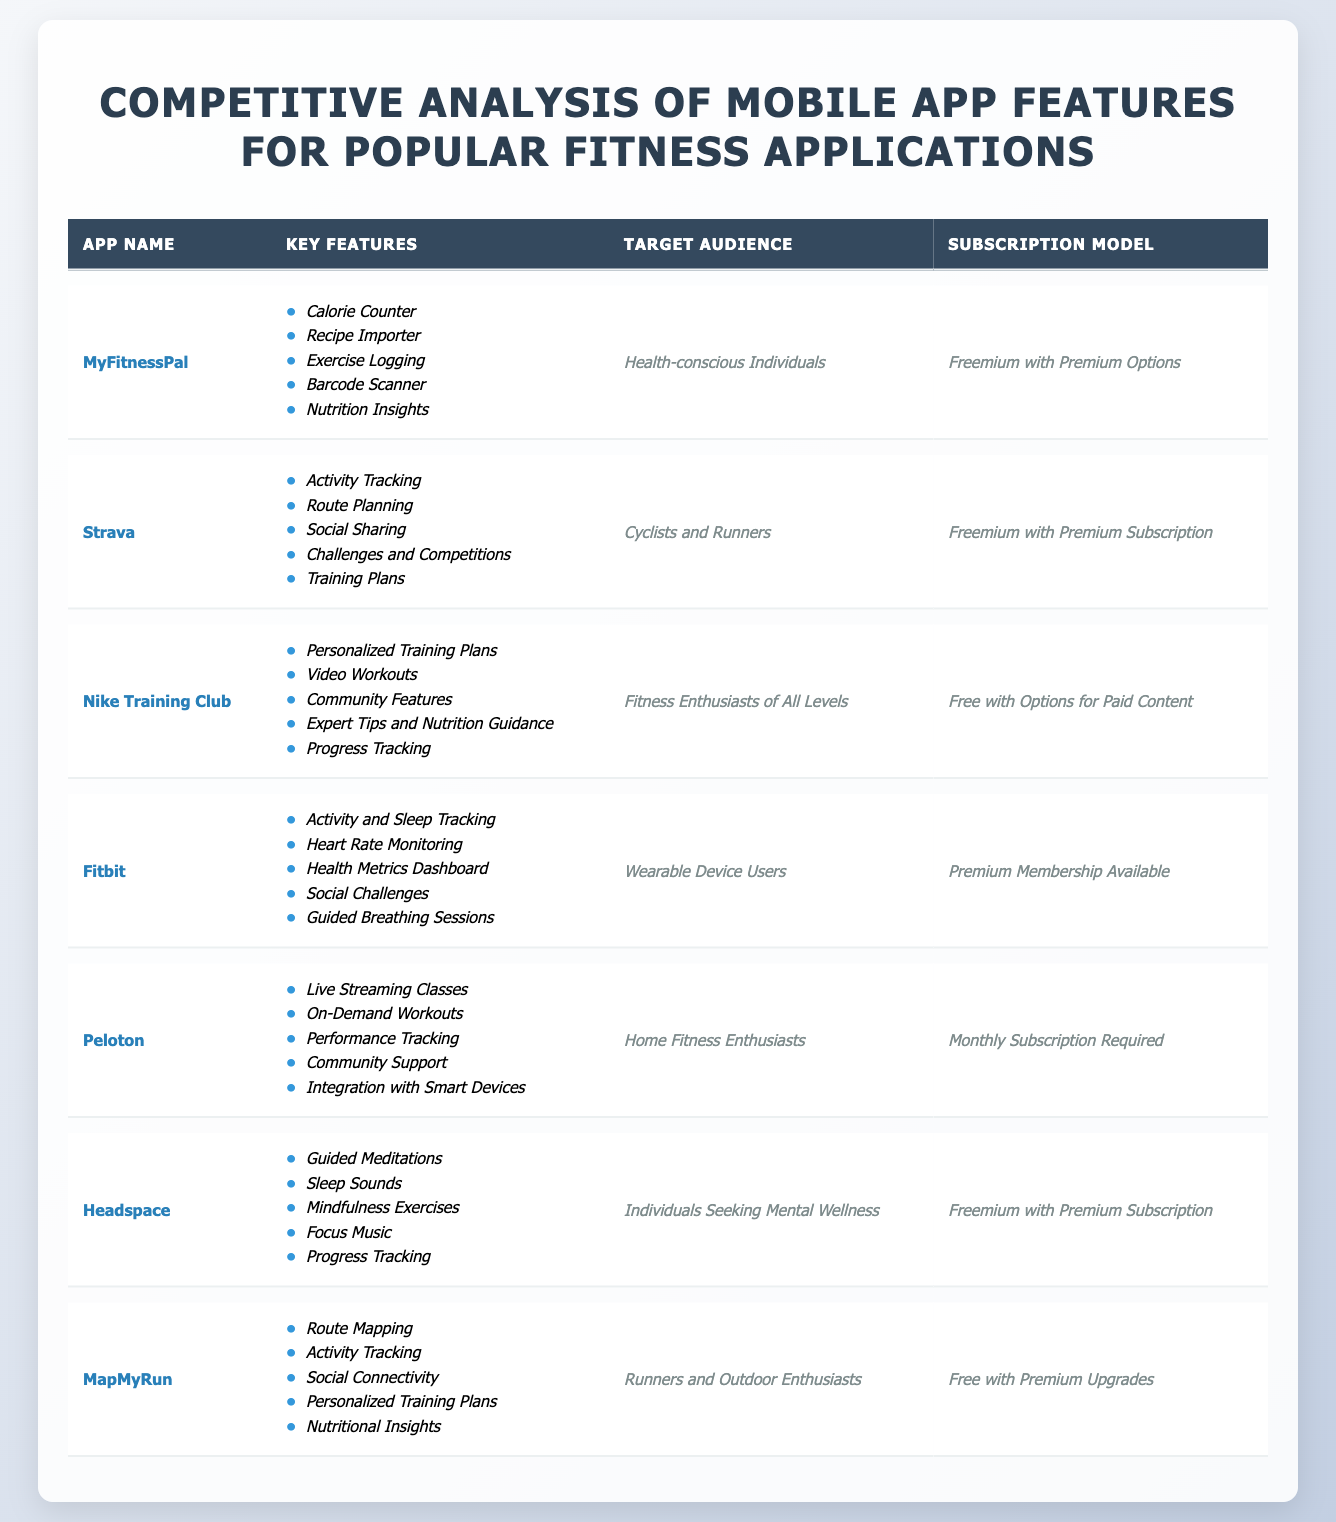What are the key features of MyFitnessPal? MyFitnessPal has a list of key features that include *Calorie Counter*, *Recipe Importer*, *Exercise Logging*, *Barcode Scanner*, and *Nutrition Insights*. These features are listed directly in the table under the Key Features column.
Answer: *Calorie Counter*, *Recipe Importer*, *Exercise Logging*, *Barcode Scanner*, *Nutrition Insights* Which app is targeted towards cyclists and runners? The target audience for the app Strava is explicitly mentioned in the table as *Cyclists and Runners*. Therefore, Strava is specifically aimed at this demographic.
Answer: Strava How many apps offer a freemium subscription model? There are three applications that offer a freemium subscription model: MyFitnessPal, Strava, and Headspace. This can be deduced by counting the apps that have *Freemium with Premium Options* or similar descriptions in the Subscription Model column.
Answer: 3 Does Nike Training Club provide personalized training plans? Yes, Nike Training Club does offer *Personalized Training Plans*, which are listed among its key features in the table.
Answer: Yes Which app has the feature for guided meditations? The app Headspace offers *Guided Meditations*, as noted in its Key Features. This is a direct retrieval from the table.
Answer: Headspace What is the target audience for Fitbit? The table states that the target audience for Fitbit is *Wearable Device Users*, which can be directly referred to from the Target Audience column.
Answer: *Wearable Device Users* Which fitness app has live streaming classes? Peloton has *Live Streaming Classes* among its key features, as indicated in the Key Features column of the table.
Answer: Peloton Among the listed apps, which one has the least number of key features? Nike Training Club and Headspace each have 5 key features. However, in comparison to the other apps, they don't have fewer than 5 features, thus no app has fewer than any other listed. The most feature-rich app is Peloton with 5 as well, making it average among the others.
Answer: 5 How many apps provide features related to activity tracking? Four applications offer features related to activity tracking: MyFitnessPal, Strava, Fitbit, and MapMyRun, as each has *Activity Tracking* listed in their Key Features.
Answer: 4 If a user is looking for an app for home fitness, which app should they consider? A user should consider Peloton, as it is specifically targeted towards *Home Fitness Enthusiasts* as indicated in the Target Audience section of the table.
Answer: Peloton 